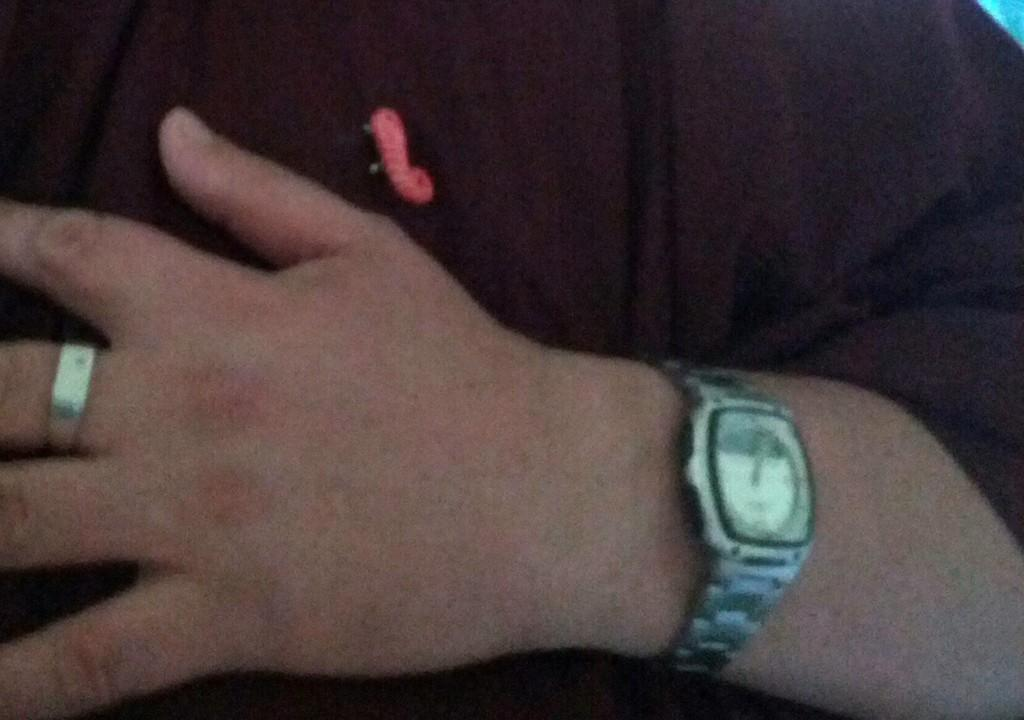What part of the body is visible in the image? There is a person's hand in the image. What accessories are on the hand? The hand has a watch and a ring on it. What type of material can be seen in the image? There is cloth visible in the image. What type of locket can be seen hanging from the car in the image? There is no car or locket present in the image; it only features a person's hand with a watch and a ring. 